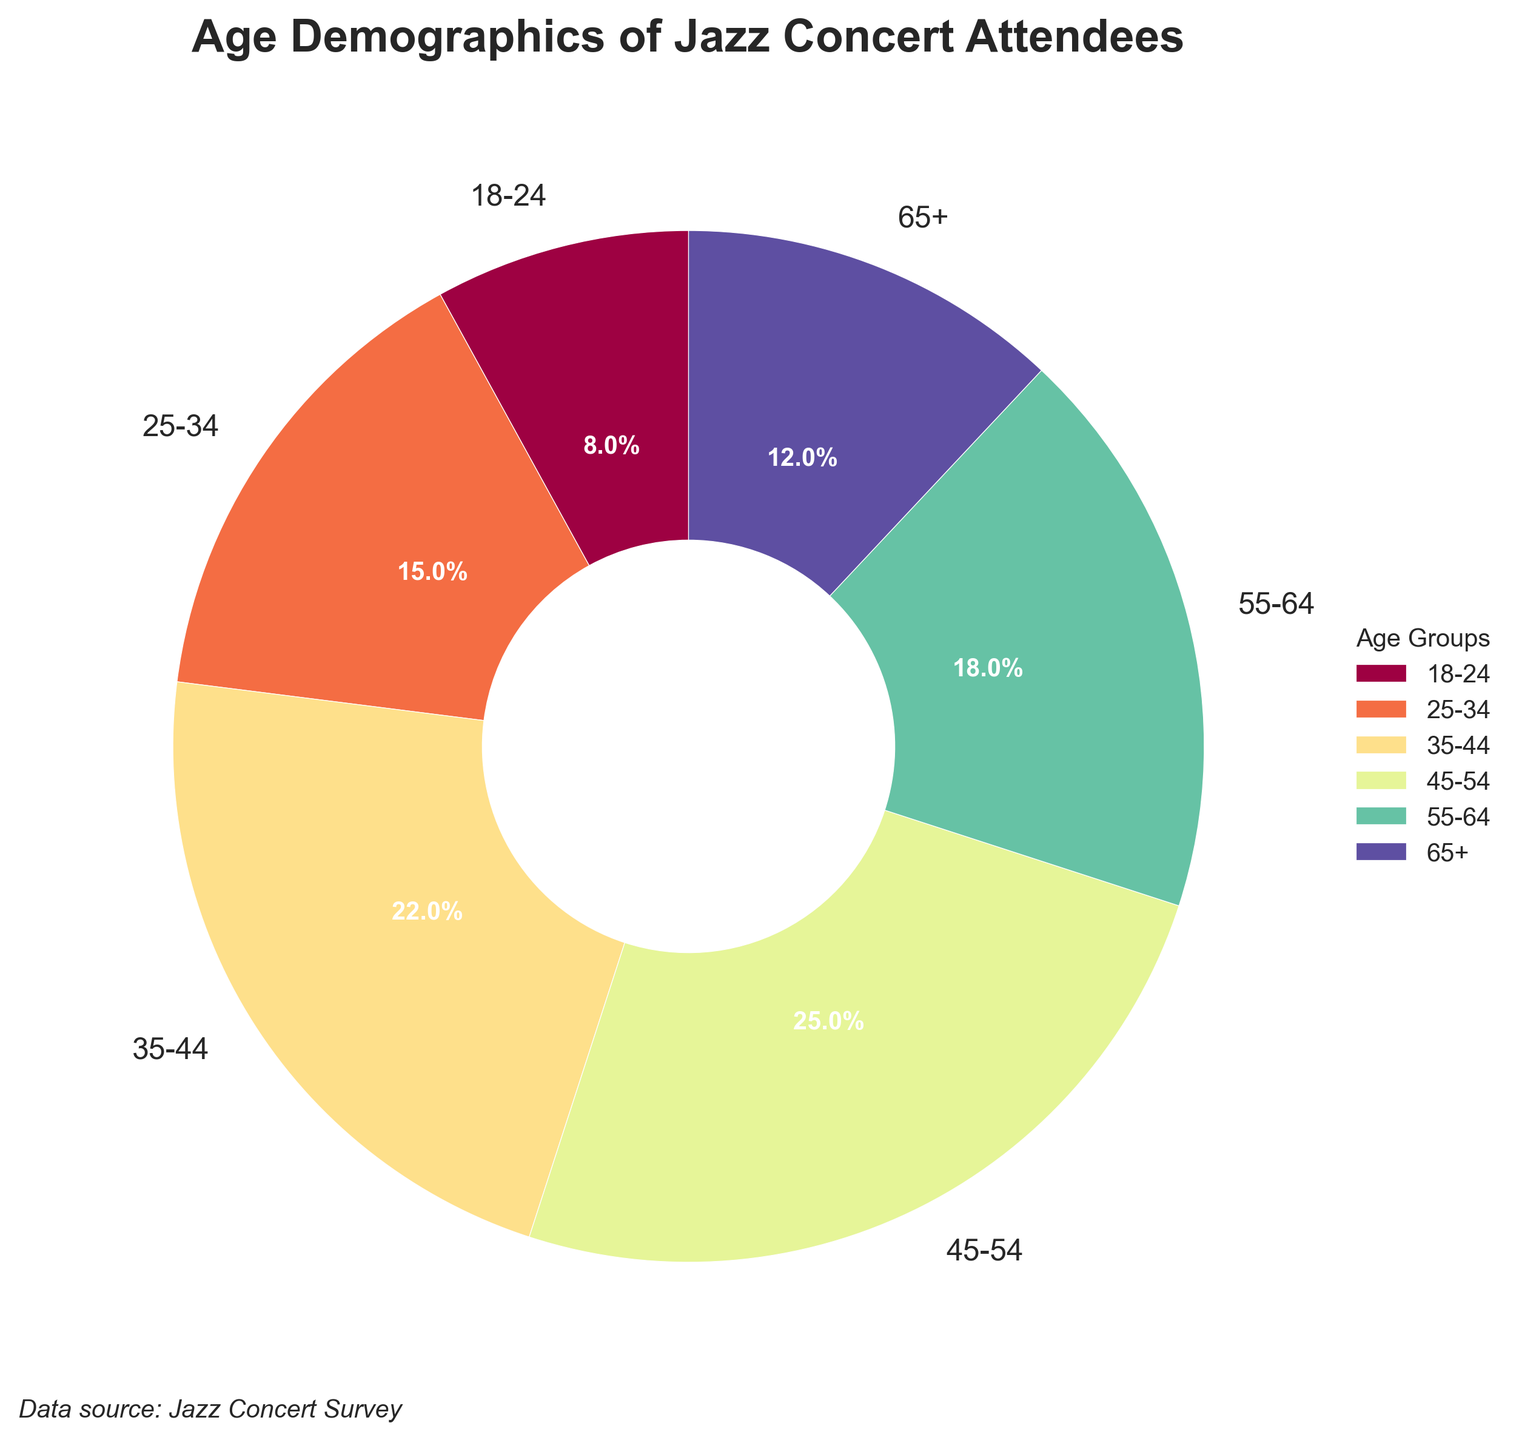What percentage of attendees are aged between 35 and 54? Adding the percentages of the 35-44 age group (22%) and the 45-54 age group (25%) gives 22% + 25% = 47%
Answer: 47% Which age group has the lowest percentage of attendees? Looking at the pie chart, the 18-24 age group has the smallest slice, which represents 8% of the attendees
Answer: 18-24 How does the percentage of attendees aged 65+ compare to those aged 55-64? The percentage of attendees aged 65+ is 12%, which is less than the 18% of attendees aged 55-64
Answer: 65+ has fewer attendees than 55-64 What is the total percentage of attendees aged 25-34 and 65+ combined? Adding the percentages of the 25-34 age group (15%) and the 65+ age group (12%) gives 15% + 12% = 27%
Answer: 27% What is the difference in percentage between the 45-54 age group and the 18-24 age group? Subtracting the percentage of the 18-24 age group (8%) from the 45-54 age group (25%) gives 25% - 8% = 17%
Answer: 17% Which two age groups together account for less than 25% of the attendees? The 18-24 age group (8%) and the 65+ age group (12%) together make 8% + 12% = 20%, which is less than 25%
Answer: 18-24 and 65+ How does the percentage of attendees aged 35-44 compare to those aged 18-24? The percentage of attendees aged 35-44 is 22%, which is significantly higher than the 8% of attendees aged 18-24
Answer: 35-44 has more attendees than 18-24 